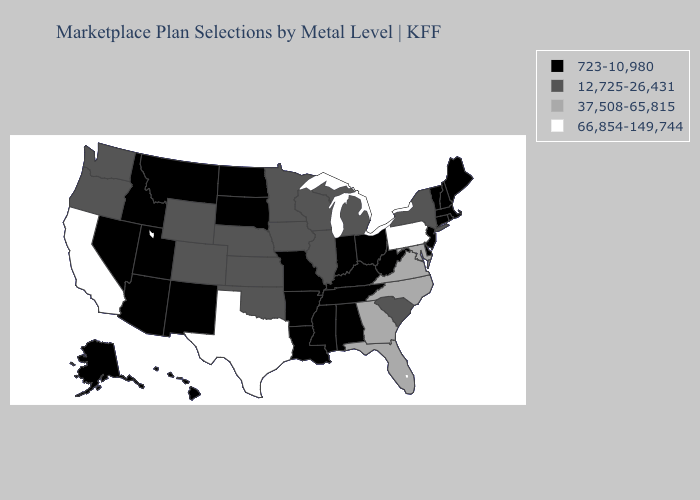Name the states that have a value in the range 37,508-65,815?
Give a very brief answer. Florida, Georgia, Maryland, North Carolina, Virginia. Which states hav the highest value in the South?
Keep it brief. Texas. Does Alabama have the same value as Illinois?
Give a very brief answer. No. Name the states that have a value in the range 12,725-26,431?
Give a very brief answer. Colorado, Illinois, Iowa, Kansas, Michigan, Minnesota, Nebraska, New York, Oklahoma, Oregon, South Carolina, Washington, Wisconsin, Wyoming. Does Florida have a higher value than Pennsylvania?
Write a very short answer. No. Which states hav the highest value in the West?
Give a very brief answer. California. Is the legend a continuous bar?
Be succinct. No. Does South Dakota have the lowest value in the MidWest?
Answer briefly. Yes. Which states have the lowest value in the USA?
Quick response, please. Alabama, Alaska, Arizona, Arkansas, Connecticut, Delaware, Hawaii, Idaho, Indiana, Kentucky, Louisiana, Maine, Massachusetts, Mississippi, Missouri, Montana, Nevada, New Hampshire, New Jersey, New Mexico, North Dakota, Ohio, Rhode Island, South Dakota, Tennessee, Utah, Vermont, West Virginia. Does California have the highest value in the USA?
Write a very short answer. Yes. What is the value of Oklahoma?
Write a very short answer. 12,725-26,431. Does Georgia have the same value as Minnesota?
Give a very brief answer. No. Name the states that have a value in the range 66,854-149,744?
Keep it brief. California, Pennsylvania, Texas. What is the value of North Carolina?
Write a very short answer. 37,508-65,815. Does the map have missing data?
Be succinct. No. 